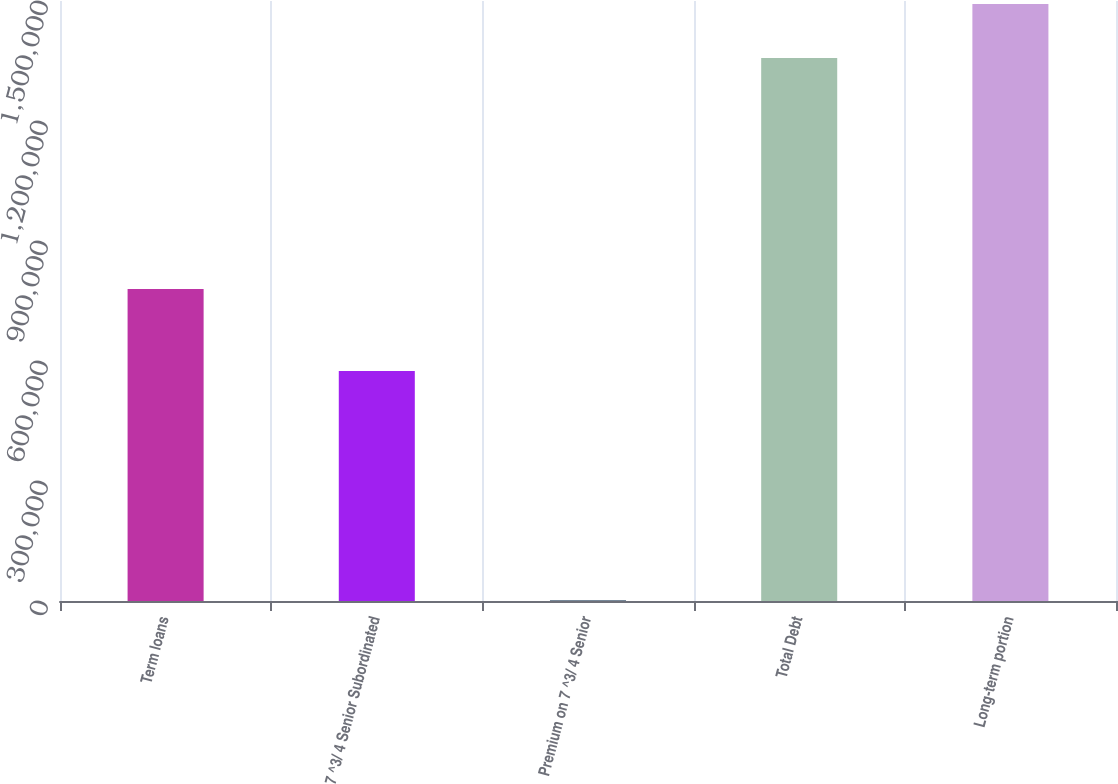Convert chart. <chart><loc_0><loc_0><loc_500><loc_500><bar_chart><fcel>Term loans<fcel>7 ^3/ 4 Senior Subordinated<fcel>Premium on 7 ^3/ 4 Senior<fcel>Total Debt<fcel>Long-term portion<nl><fcel>780000<fcel>575000<fcel>2230<fcel>1.35723e+06<fcel>1.49273e+06<nl></chart> 